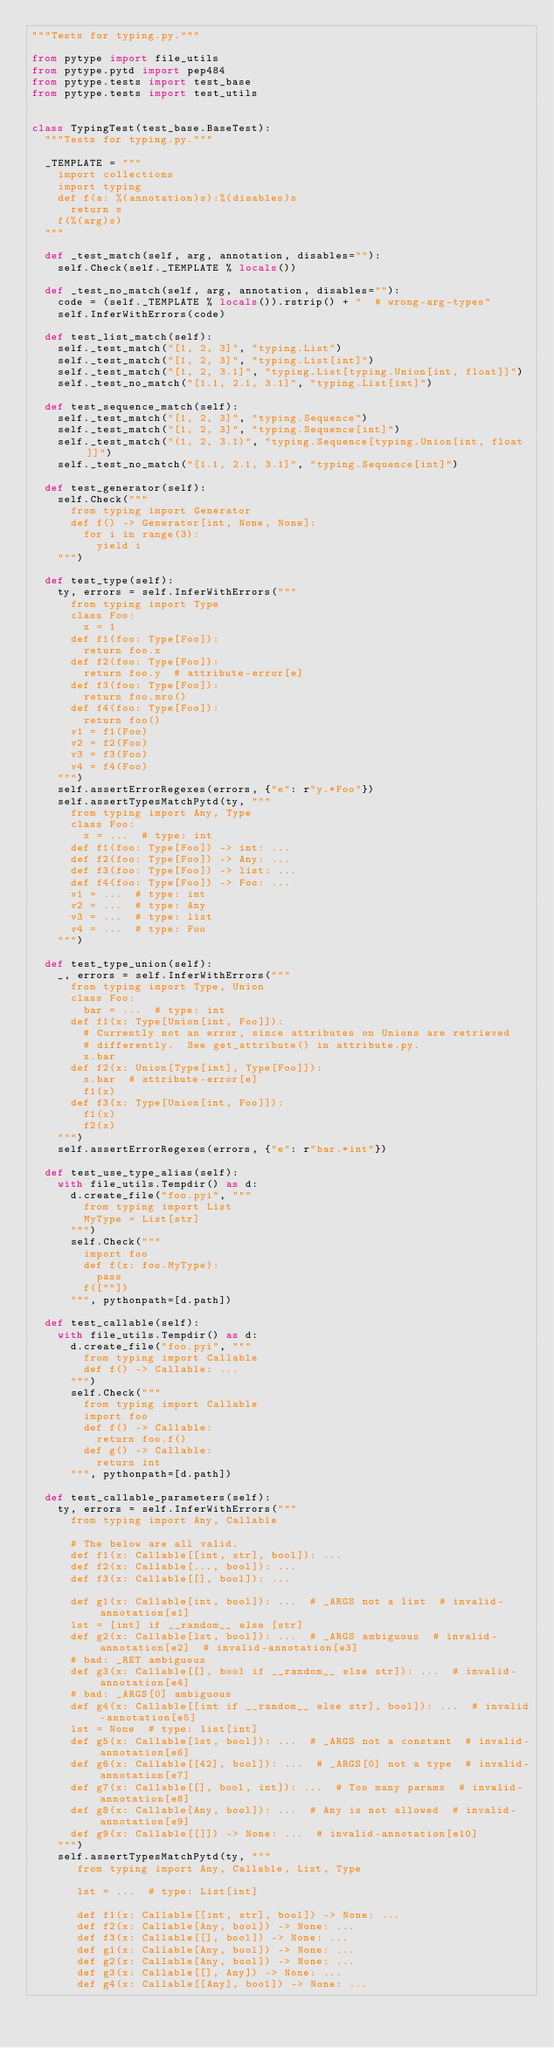Convert code to text. <code><loc_0><loc_0><loc_500><loc_500><_Python_>"""Tests for typing.py."""

from pytype import file_utils
from pytype.pytd import pep484
from pytype.tests import test_base
from pytype.tests import test_utils


class TypingTest(test_base.BaseTest):
  """Tests for typing.py."""

  _TEMPLATE = """
    import collections
    import typing
    def f(s: %(annotation)s):%(disables)s
      return s
    f(%(arg)s)
  """

  def _test_match(self, arg, annotation, disables=""):
    self.Check(self._TEMPLATE % locals())

  def _test_no_match(self, arg, annotation, disables=""):
    code = (self._TEMPLATE % locals()).rstrip() + "  # wrong-arg-types"
    self.InferWithErrors(code)

  def test_list_match(self):
    self._test_match("[1, 2, 3]", "typing.List")
    self._test_match("[1, 2, 3]", "typing.List[int]")
    self._test_match("[1, 2, 3.1]", "typing.List[typing.Union[int, float]]")
    self._test_no_match("[1.1, 2.1, 3.1]", "typing.List[int]")

  def test_sequence_match(self):
    self._test_match("[1, 2, 3]", "typing.Sequence")
    self._test_match("[1, 2, 3]", "typing.Sequence[int]")
    self._test_match("(1, 2, 3.1)", "typing.Sequence[typing.Union[int, float]]")
    self._test_no_match("[1.1, 2.1, 3.1]", "typing.Sequence[int]")

  def test_generator(self):
    self.Check("""
      from typing import Generator
      def f() -> Generator[int, None, None]:
        for i in range(3):
          yield i
    """)

  def test_type(self):
    ty, errors = self.InferWithErrors("""
      from typing import Type
      class Foo:
        x = 1
      def f1(foo: Type[Foo]):
        return foo.x
      def f2(foo: Type[Foo]):
        return foo.y  # attribute-error[e]
      def f3(foo: Type[Foo]):
        return foo.mro()
      def f4(foo: Type[Foo]):
        return foo()
      v1 = f1(Foo)
      v2 = f2(Foo)
      v3 = f3(Foo)
      v4 = f4(Foo)
    """)
    self.assertErrorRegexes(errors, {"e": r"y.*Foo"})
    self.assertTypesMatchPytd(ty, """
      from typing import Any, Type
      class Foo:
        x = ...  # type: int
      def f1(foo: Type[Foo]) -> int: ...
      def f2(foo: Type[Foo]) -> Any: ...
      def f3(foo: Type[Foo]) -> list: ...
      def f4(foo: Type[Foo]) -> Foo: ...
      v1 = ...  # type: int
      v2 = ...  # type: Any
      v3 = ...  # type: list
      v4 = ...  # type: Foo
    """)

  def test_type_union(self):
    _, errors = self.InferWithErrors("""
      from typing import Type, Union
      class Foo:
        bar = ...  # type: int
      def f1(x: Type[Union[int, Foo]]):
        # Currently not an error, since attributes on Unions are retrieved
        # differently.  See get_attribute() in attribute.py.
        x.bar
      def f2(x: Union[Type[int], Type[Foo]]):
        x.bar  # attribute-error[e]
        f1(x)
      def f3(x: Type[Union[int, Foo]]):
        f1(x)
        f2(x)
    """)
    self.assertErrorRegexes(errors, {"e": r"bar.*int"})

  def test_use_type_alias(self):
    with file_utils.Tempdir() as d:
      d.create_file("foo.pyi", """
        from typing import List
        MyType = List[str]
      """)
      self.Check("""
        import foo
        def f(x: foo.MyType):
          pass
        f([""])
      """, pythonpath=[d.path])

  def test_callable(self):
    with file_utils.Tempdir() as d:
      d.create_file("foo.pyi", """
        from typing import Callable
        def f() -> Callable: ...
      """)
      self.Check("""
        from typing import Callable
        import foo
        def f() -> Callable:
          return foo.f()
        def g() -> Callable:
          return int
      """, pythonpath=[d.path])

  def test_callable_parameters(self):
    ty, errors = self.InferWithErrors("""
      from typing import Any, Callable

      # The below are all valid.
      def f1(x: Callable[[int, str], bool]): ...
      def f2(x: Callable[..., bool]): ...
      def f3(x: Callable[[], bool]): ...

      def g1(x: Callable[int, bool]): ...  # _ARGS not a list  # invalid-annotation[e1]
      lst = [int] if __random__ else [str]
      def g2(x: Callable[lst, bool]): ...  # _ARGS ambiguous  # invalid-annotation[e2]  # invalid-annotation[e3]
      # bad: _RET ambiguous
      def g3(x: Callable[[], bool if __random__ else str]): ...  # invalid-annotation[e4]
      # bad: _ARGS[0] ambiguous
      def g4(x: Callable[[int if __random__ else str], bool]): ...  # invalid-annotation[e5]
      lst = None  # type: list[int]
      def g5(x: Callable[lst, bool]): ...  # _ARGS not a constant  # invalid-annotation[e6]
      def g6(x: Callable[[42], bool]): ...  # _ARGS[0] not a type  # invalid-annotation[e7]
      def g7(x: Callable[[], bool, int]): ...  # Too many params  # invalid-annotation[e8]
      def g8(x: Callable[Any, bool]): ...  # Any is not allowed  # invalid-annotation[e9]
      def g9(x: Callable[[]]) -> None: ...  # invalid-annotation[e10]
    """)
    self.assertTypesMatchPytd(ty, """
       from typing import Any, Callable, List, Type

       lst = ...  # type: List[int]

       def f1(x: Callable[[int, str], bool]) -> None: ...
       def f2(x: Callable[Any, bool]) -> None: ...
       def f3(x: Callable[[], bool]) -> None: ...
       def g1(x: Callable[Any, bool]) -> None: ...
       def g2(x: Callable[Any, bool]) -> None: ...
       def g3(x: Callable[[], Any]) -> None: ...
       def g4(x: Callable[[Any], bool]) -> None: ...</code> 